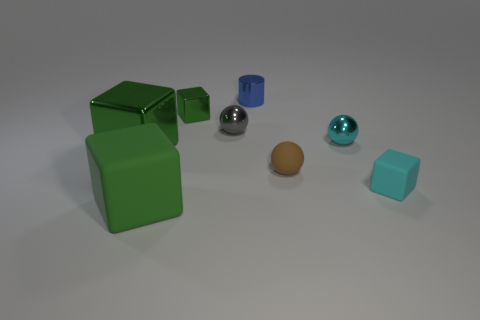There is a object that is the same color as the tiny matte cube; what shape is it?
Ensure brevity in your answer.  Sphere. What number of things are either large gray metallic things or small shiny things?
Keep it short and to the point. 4. Is the cyan sphere made of the same material as the thing that is behind the small green cube?
Make the answer very short. Yes. Is there anything else that has the same color as the large metal cube?
Offer a terse response. Yes. What number of objects are either tiny rubber things in front of the tiny brown rubber object or things that are behind the small brown matte thing?
Provide a succinct answer. 6. What is the shape of the tiny thing that is behind the brown object and to the right of the tiny shiny cylinder?
Make the answer very short. Sphere. There is a green thing in front of the large metal thing; how many things are right of it?
Give a very brief answer. 6. What number of things are either things that are behind the cyan metallic sphere or tiny green metal things?
Ensure brevity in your answer.  3. There is a metallic thing on the right side of the brown rubber ball; what size is it?
Provide a short and direct response. Small. What is the material of the small cyan cube?
Your answer should be compact. Rubber. 